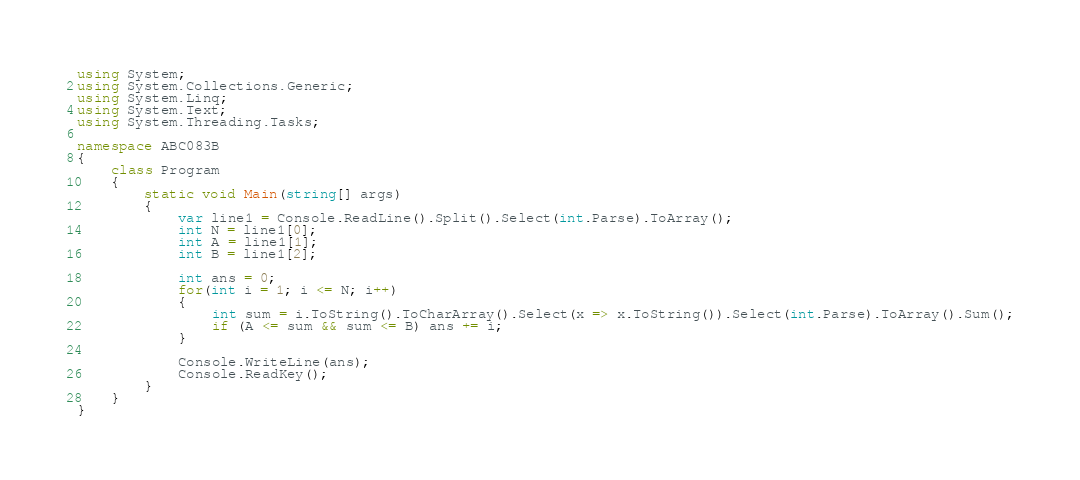<code> <loc_0><loc_0><loc_500><loc_500><_C#_>using System;
using System.Collections.Generic;
using System.Linq;
using System.Text;
using System.Threading.Tasks;

namespace ABC083B
{
    class Program
    {
        static void Main(string[] args)
        {
            var line1 = Console.ReadLine().Split().Select(int.Parse).ToArray();
            int N = line1[0];
            int A = line1[1];
            int B = line1[2];

            int ans = 0;
            for(int i = 1; i <= N; i++)
            {
                int sum = i.ToString().ToCharArray().Select(x => x.ToString()).Select(int.Parse).ToArray().Sum();
                if (A <= sum && sum <= B) ans += i;
            }

            Console.WriteLine(ans);
            Console.ReadKey();
        }
    }
}
</code> 